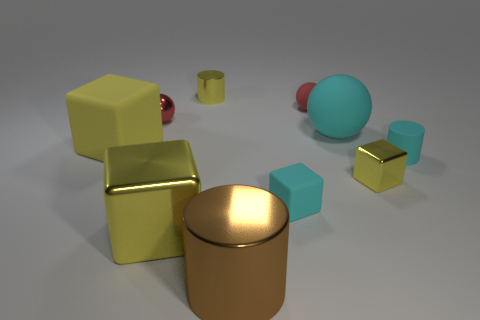Subtract all yellow blocks. How many were subtracted if there are1yellow blocks left? 2 Subtract all red cylinders. How many yellow cubes are left? 3 Subtract all cylinders. How many objects are left? 7 Subtract all big yellow metallic things. Subtract all small matte things. How many objects are left? 6 Add 5 big brown metallic objects. How many big brown metallic objects are left? 6 Add 7 metal cubes. How many metal cubes exist? 9 Subtract 1 cyan cylinders. How many objects are left? 9 